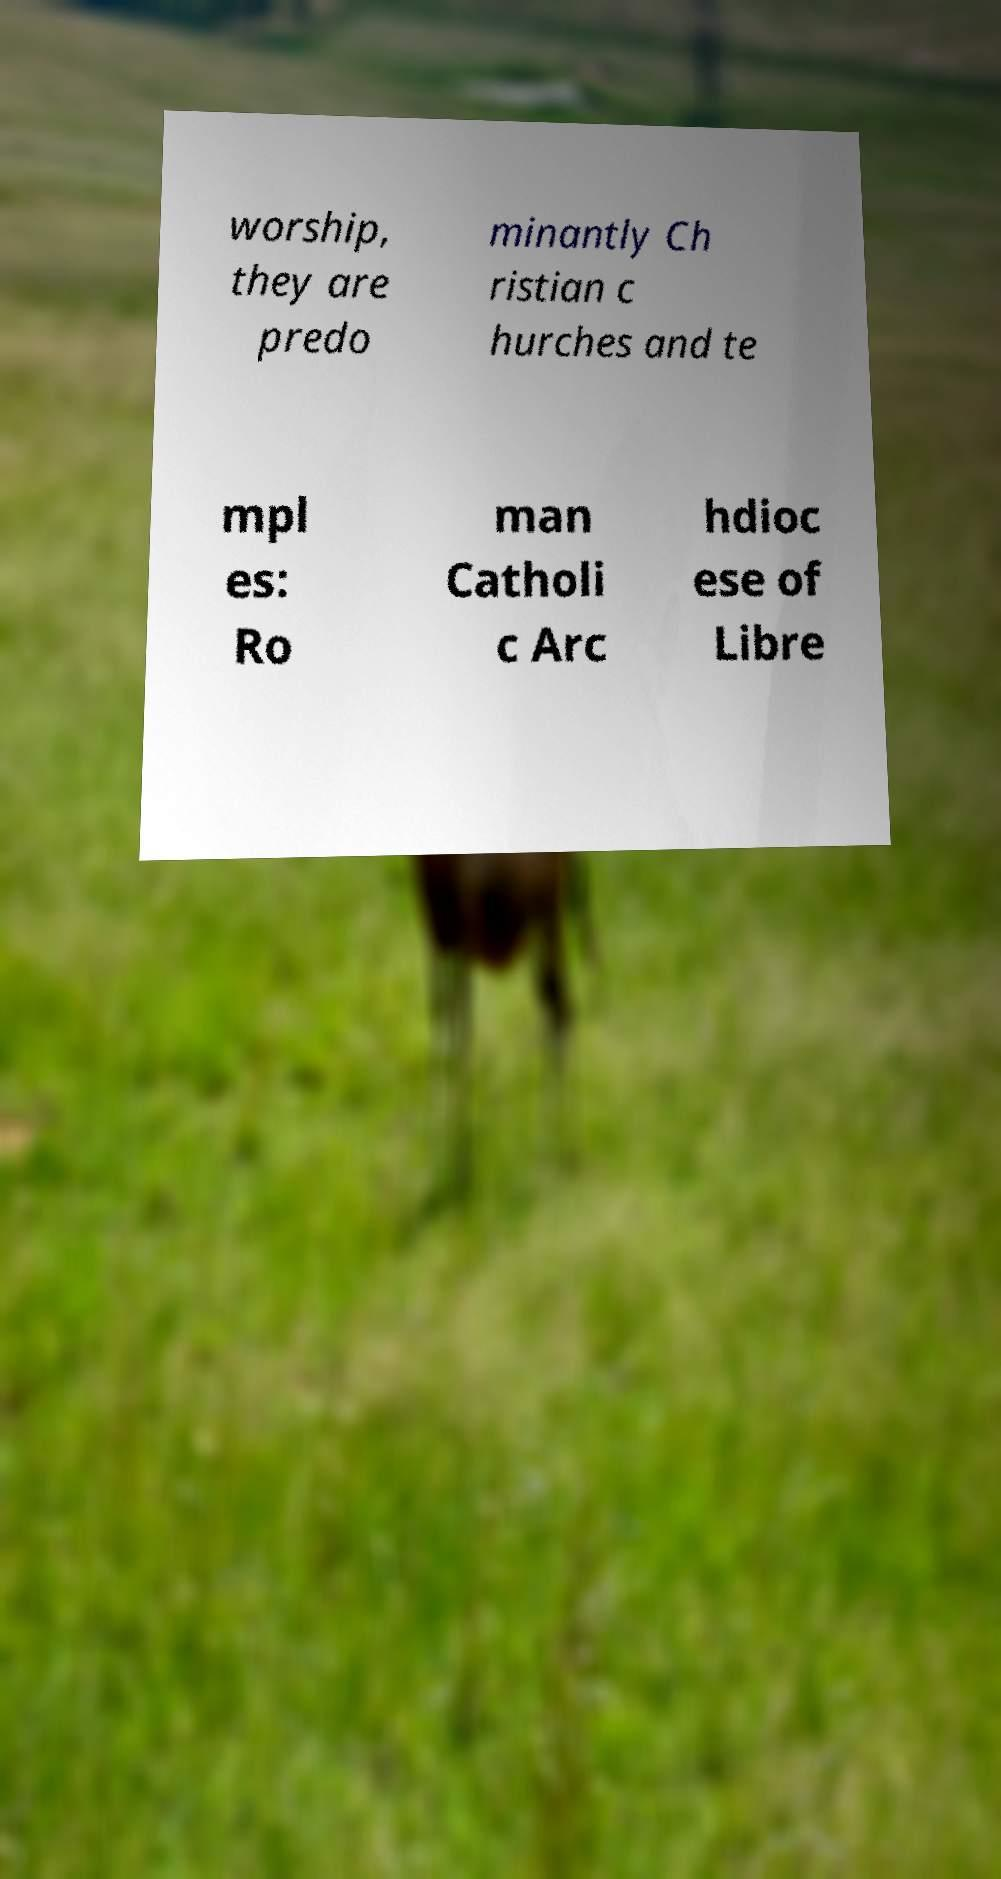For documentation purposes, I need the text within this image transcribed. Could you provide that? worship, they are predo minantly Ch ristian c hurches and te mpl es: Ro man Catholi c Arc hdioc ese of Libre 